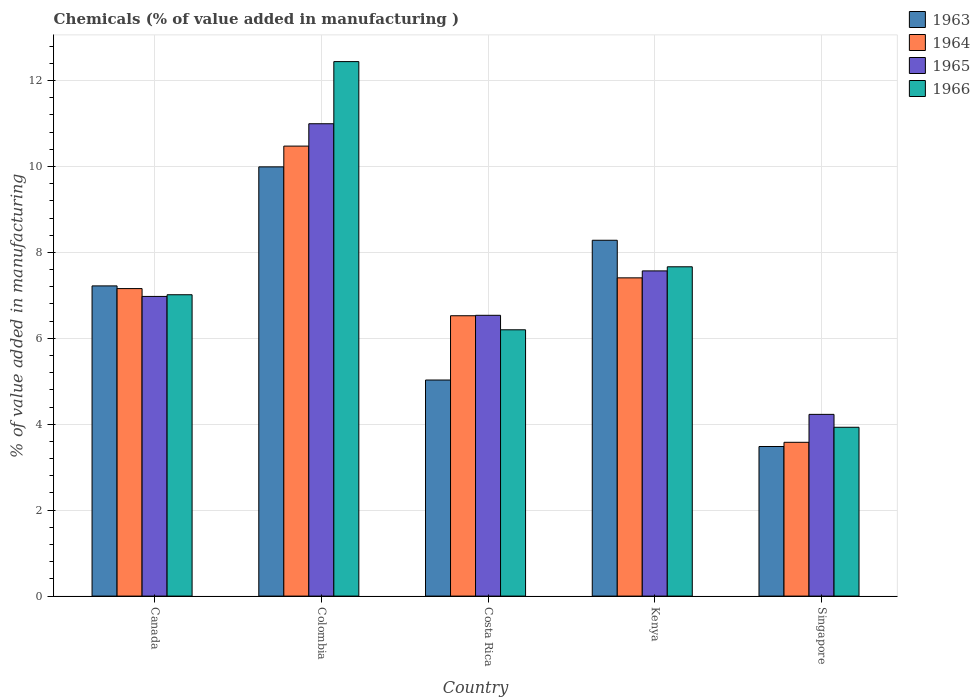How many different coloured bars are there?
Your response must be concise. 4. Are the number of bars per tick equal to the number of legend labels?
Provide a short and direct response. Yes. What is the label of the 3rd group of bars from the left?
Offer a terse response. Costa Rica. What is the value added in manufacturing chemicals in 1963 in Kenya?
Offer a terse response. 8.28. Across all countries, what is the maximum value added in manufacturing chemicals in 1965?
Ensure brevity in your answer.  10.99. Across all countries, what is the minimum value added in manufacturing chemicals in 1966?
Keep it short and to the point. 3.93. In which country was the value added in manufacturing chemicals in 1966 minimum?
Offer a terse response. Singapore. What is the total value added in manufacturing chemicals in 1963 in the graph?
Give a very brief answer. 34.01. What is the difference between the value added in manufacturing chemicals in 1966 in Costa Rica and that in Kenya?
Give a very brief answer. -1.47. What is the difference between the value added in manufacturing chemicals in 1966 in Kenya and the value added in manufacturing chemicals in 1965 in Colombia?
Your response must be concise. -3.33. What is the average value added in manufacturing chemicals in 1964 per country?
Ensure brevity in your answer.  7.03. What is the difference between the value added in manufacturing chemicals of/in 1966 and value added in manufacturing chemicals of/in 1963 in Singapore?
Provide a short and direct response. 0.45. What is the ratio of the value added in manufacturing chemicals in 1964 in Canada to that in Costa Rica?
Give a very brief answer. 1.1. Is the value added in manufacturing chemicals in 1963 in Canada less than that in Costa Rica?
Offer a terse response. No. What is the difference between the highest and the second highest value added in manufacturing chemicals in 1963?
Provide a succinct answer. -1.71. What is the difference between the highest and the lowest value added in manufacturing chemicals in 1963?
Your response must be concise. 6.51. Is the sum of the value added in manufacturing chemicals in 1966 in Canada and Colombia greater than the maximum value added in manufacturing chemicals in 1963 across all countries?
Make the answer very short. Yes. Is it the case that in every country, the sum of the value added in manufacturing chemicals in 1963 and value added in manufacturing chemicals in 1965 is greater than the sum of value added in manufacturing chemicals in 1966 and value added in manufacturing chemicals in 1964?
Provide a short and direct response. No. What does the 4th bar from the left in Canada represents?
Give a very brief answer. 1966. What does the 1st bar from the right in Costa Rica represents?
Ensure brevity in your answer.  1966. Are all the bars in the graph horizontal?
Provide a succinct answer. No. Does the graph contain any zero values?
Your answer should be compact. No. Does the graph contain grids?
Offer a terse response. Yes. Where does the legend appear in the graph?
Make the answer very short. Top right. How are the legend labels stacked?
Your answer should be very brief. Vertical. What is the title of the graph?
Provide a short and direct response. Chemicals (% of value added in manufacturing ). What is the label or title of the X-axis?
Your response must be concise. Country. What is the label or title of the Y-axis?
Your response must be concise. % of value added in manufacturing. What is the % of value added in manufacturing of 1963 in Canada?
Your answer should be compact. 7.22. What is the % of value added in manufacturing in 1964 in Canada?
Keep it short and to the point. 7.16. What is the % of value added in manufacturing in 1965 in Canada?
Your answer should be compact. 6.98. What is the % of value added in manufacturing of 1966 in Canada?
Offer a very short reply. 7.01. What is the % of value added in manufacturing of 1963 in Colombia?
Offer a terse response. 9.99. What is the % of value added in manufacturing of 1964 in Colombia?
Give a very brief answer. 10.47. What is the % of value added in manufacturing of 1965 in Colombia?
Keep it short and to the point. 10.99. What is the % of value added in manufacturing of 1966 in Colombia?
Your answer should be compact. 12.44. What is the % of value added in manufacturing in 1963 in Costa Rica?
Your response must be concise. 5.03. What is the % of value added in manufacturing in 1964 in Costa Rica?
Offer a terse response. 6.53. What is the % of value added in manufacturing of 1965 in Costa Rica?
Keep it short and to the point. 6.54. What is the % of value added in manufacturing in 1966 in Costa Rica?
Make the answer very short. 6.2. What is the % of value added in manufacturing in 1963 in Kenya?
Your response must be concise. 8.28. What is the % of value added in manufacturing in 1964 in Kenya?
Your answer should be very brief. 7.41. What is the % of value added in manufacturing in 1965 in Kenya?
Offer a terse response. 7.57. What is the % of value added in manufacturing of 1966 in Kenya?
Your answer should be very brief. 7.67. What is the % of value added in manufacturing in 1963 in Singapore?
Offer a very short reply. 3.48. What is the % of value added in manufacturing of 1964 in Singapore?
Your response must be concise. 3.58. What is the % of value added in manufacturing in 1965 in Singapore?
Provide a short and direct response. 4.23. What is the % of value added in manufacturing in 1966 in Singapore?
Give a very brief answer. 3.93. Across all countries, what is the maximum % of value added in manufacturing of 1963?
Your response must be concise. 9.99. Across all countries, what is the maximum % of value added in manufacturing in 1964?
Provide a succinct answer. 10.47. Across all countries, what is the maximum % of value added in manufacturing in 1965?
Ensure brevity in your answer.  10.99. Across all countries, what is the maximum % of value added in manufacturing in 1966?
Offer a very short reply. 12.44. Across all countries, what is the minimum % of value added in manufacturing in 1963?
Offer a very short reply. 3.48. Across all countries, what is the minimum % of value added in manufacturing of 1964?
Offer a very short reply. 3.58. Across all countries, what is the minimum % of value added in manufacturing of 1965?
Provide a succinct answer. 4.23. Across all countries, what is the minimum % of value added in manufacturing of 1966?
Give a very brief answer. 3.93. What is the total % of value added in manufacturing in 1963 in the graph?
Ensure brevity in your answer.  34.01. What is the total % of value added in manufacturing in 1964 in the graph?
Offer a very short reply. 35.15. What is the total % of value added in manufacturing of 1965 in the graph?
Provide a short and direct response. 36.31. What is the total % of value added in manufacturing of 1966 in the graph?
Make the answer very short. 37.25. What is the difference between the % of value added in manufacturing in 1963 in Canada and that in Colombia?
Provide a short and direct response. -2.77. What is the difference between the % of value added in manufacturing in 1964 in Canada and that in Colombia?
Provide a short and direct response. -3.32. What is the difference between the % of value added in manufacturing of 1965 in Canada and that in Colombia?
Ensure brevity in your answer.  -4.02. What is the difference between the % of value added in manufacturing in 1966 in Canada and that in Colombia?
Offer a terse response. -5.43. What is the difference between the % of value added in manufacturing of 1963 in Canada and that in Costa Rica?
Your answer should be very brief. 2.19. What is the difference between the % of value added in manufacturing in 1964 in Canada and that in Costa Rica?
Keep it short and to the point. 0.63. What is the difference between the % of value added in manufacturing of 1965 in Canada and that in Costa Rica?
Provide a succinct answer. 0.44. What is the difference between the % of value added in manufacturing in 1966 in Canada and that in Costa Rica?
Provide a succinct answer. 0.82. What is the difference between the % of value added in manufacturing of 1963 in Canada and that in Kenya?
Offer a very short reply. -1.06. What is the difference between the % of value added in manufacturing of 1964 in Canada and that in Kenya?
Keep it short and to the point. -0.25. What is the difference between the % of value added in manufacturing of 1965 in Canada and that in Kenya?
Offer a very short reply. -0.59. What is the difference between the % of value added in manufacturing in 1966 in Canada and that in Kenya?
Keep it short and to the point. -0.65. What is the difference between the % of value added in manufacturing in 1963 in Canada and that in Singapore?
Your response must be concise. 3.74. What is the difference between the % of value added in manufacturing of 1964 in Canada and that in Singapore?
Offer a terse response. 3.58. What is the difference between the % of value added in manufacturing of 1965 in Canada and that in Singapore?
Provide a succinct answer. 2.75. What is the difference between the % of value added in manufacturing of 1966 in Canada and that in Singapore?
Ensure brevity in your answer.  3.08. What is the difference between the % of value added in manufacturing in 1963 in Colombia and that in Costa Rica?
Ensure brevity in your answer.  4.96. What is the difference between the % of value added in manufacturing of 1964 in Colombia and that in Costa Rica?
Make the answer very short. 3.95. What is the difference between the % of value added in manufacturing in 1965 in Colombia and that in Costa Rica?
Make the answer very short. 4.46. What is the difference between the % of value added in manufacturing in 1966 in Colombia and that in Costa Rica?
Provide a succinct answer. 6.24. What is the difference between the % of value added in manufacturing in 1963 in Colombia and that in Kenya?
Make the answer very short. 1.71. What is the difference between the % of value added in manufacturing of 1964 in Colombia and that in Kenya?
Provide a short and direct response. 3.07. What is the difference between the % of value added in manufacturing of 1965 in Colombia and that in Kenya?
Your answer should be very brief. 3.43. What is the difference between the % of value added in manufacturing in 1966 in Colombia and that in Kenya?
Keep it short and to the point. 4.78. What is the difference between the % of value added in manufacturing in 1963 in Colombia and that in Singapore?
Offer a very short reply. 6.51. What is the difference between the % of value added in manufacturing in 1964 in Colombia and that in Singapore?
Your answer should be very brief. 6.89. What is the difference between the % of value added in manufacturing in 1965 in Colombia and that in Singapore?
Ensure brevity in your answer.  6.76. What is the difference between the % of value added in manufacturing in 1966 in Colombia and that in Singapore?
Make the answer very short. 8.51. What is the difference between the % of value added in manufacturing of 1963 in Costa Rica and that in Kenya?
Your answer should be very brief. -3.25. What is the difference between the % of value added in manufacturing of 1964 in Costa Rica and that in Kenya?
Your response must be concise. -0.88. What is the difference between the % of value added in manufacturing in 1965 in Costa Rica and that in Kenya?
Offer a very short reply. -1.03. What is the difference between the % of value added in manufacturing in 1966 in Costa Rica and that in Kenya?
Give a very brief answer. -1.47. What is the difference between the % of value added in manufacturing in 1963 in Costa Rica and that in Singapore?
Ensure brevity in your answer.  1.55. What is the difference between the % of value added in manufacturing of 1964 in Costa Rica and that in Singapore?
Provide a succinct answer. 2.95. What is the difference between the % of value added in manufacturing of 1965 in Costa Rica and that in Singapore?
Offer a terse response. 2.31. What is the difference between the % of value added in manufacturing in 1966 in Costa Rica and that in Singapore?
Make the answer very short. 2.27. What is the difference between the % of value added in manufacturing of 1963 in Kenya and that in Singapore?
Your answer should be compact. 4.8. What is the difference between the % of value added in manufacturing of 1964 in Kenya and that in Singapore?
Make the answer very short. 3.83. What is the difference between the % of value added in manufacturing in 1965 in Kenya and that in Singapore?
Your response must be concise. 3.34. What is the difference between the % of value added in manufacturing of 1966 in Kenya and that in Singapore?
Ensure brevity in your answer.  3.74. What is the difference between the % of value added in manufacturing in 1963 in Canada and the % of value added in manufacturing in 1964 in Colombia?
Your answer should be compact. -3.25. What is the difference between the % of value added in manufacturing in 1963 in Canada and the % of value added in manufacturing in 1965 in Colombia?
Your answer should be very brief. -3.77. What is the difference between the % of value added in manufacturing of 1963 in Canada and the % of value added in manufacturing of 1966 in Colombia?
Offer a very short reply. -5.22. What is the difference between the % of value added in manufacturing of 1964 in Canada and the % of value added in manufacturing of 1965 in Colombia?
Provide a succinct answer. -3.84. What is the difference between the % of value added in manufacturing in 1964 in Canada and the % of value added in manufacturing in 1966 in Colombia?
Keep it short and to the point. -5.28. What is the difference between the % of value added in manufacturing in 1965 in Canada and the % of value added in manufacturing in 1966 in Colombia?
Ensure brevity in your answer.  -5.47. What is the difference between the % of value added in manufacturing of 1963 in Canada and the % of value added in manufacturing of 1964 in Costa Rica?
Offer a terse response. 0.69. What is the difference between the % of value added in manufacturing of 1963 in Canada and the % of value added in manufacturing of 1965 in Costa Rica?
Your response must be concise. 0.68. What is the difference between the % of value added in manufacturing in 1963 in Canada and the % of value added in manufacturing in 1966 in Costa Rica?
Keep it short and to the point. 1.02. What is the difference between the % of value added in manufacturing in 1964 in Canada and the % of value added in manufacturing in 1965 in Costa Rica?
Offer a terse response. 0.62. What is the difference between the % of value added in manufacturing in 1964 in Canada and the % of value added in manufacturing in 1966 in Costa Rica?
Your answer should be compact. 0.96. What is the difference between the % of value added in manufacturing in 1965 in Canada and the % of value added in manufacturing in 1966 in Costa Rica?
Your response must be concise. 0.78. What is the difference between the % of value added in manufacturing of 1963 in Canada and the % of value added in manufacturing of 1964 in Kenya?
Your response must be concise. -0.19. What is the difference between the % of value added in manufacturing in 1963 in Canada and the % of value added in manufacturing in 1965 in Kenya?
Ensure brevity in your answer.  -0.35. What is the difference between the % of value added in manufacturing of 1963 in Canada and the % of value added in manufacturing of 1966 in Kenya?
Your answer should be compact. -0.44. What is the difference between the % of value added in manufacturing in 1964 in Canada and the % of value added in manufacturing in 1965 in Kenya?
Your response must be concise. -0.41. What is the difference between the % of value added in manufacturing of 1964 in Canada and the % of value added in manufacturing of 1966 in Kenya?
Keep it short and to the point. -0.51. What is the difference between the % of value added in manufacturing of 1965 in Canada and the % of value added in manufacturing of 1966 in Kenya?
Offer a terse response. -0.69. What is the difference between the % of value added in manufacturing of 1963 in Canada and the % of value added in manufacturing of 1964 in Singapore?
Your answer should be very brief. 3.64. What is the difference between the % of value added in manufacturing of 1963 in Canada and the % of value added in manufacturing of 1965 in Singapore?
Your answer should be very brief. 2.99. What is the difference between the % of value added in manufacturing in 1963 in Canada and the % of value added in manufacturing in 1966 in Singapore?
Offer a very short reply. 3.29. What is the difference between the % of value added in manufacturing in 1964 in Canada and the % of value added in manufacturing in 1965 in Singapore?
Offer a very short reply. 2.93. What is the difference between the % of value added in manufacturing of 1964 in Canada and the % of value added in manufacturing of 1966 in Singapore?
Provide a short and direct response. 3.23. What is the difference between the % of value added in manufacturing of 1965 in Canada and the % of value added in manufacturing of 1966 in Singapore?
Keep it short and to the point. 3.05. What is the difference between the % of value added in manufacturing in 1963 in Colombia and the % of value added in manufacturing in 1964 in Costa Rica?
Keep it short and to the point. 3.47. What is the difference between the % of value added in manufacturing of 1963 in Colombia and the % of value added in manufacturing of 1965 in Costa Rica?
Your answer should be compact. 3.46. What is the difference between the % of value added in manufacturing in 1963 in Colombia and the % of value added in manufacturing in 1966 in Costa Rica?
Make the answer very short. 3.79. What is the difference between the % of value added in manufacturing in 1964 in Colombia and the % of value added in manufacturing in 1965 in Costa Rica?
Provide a short and direct response. 3.94. What is the difference between the % of value added in manufacturing in 1964 in Colombia and the % of value added in manufacturing in 1966 in Costa Rica?
Your response must be concise. 4.28. What is the difference between the % of value added in manufacturing of 1965 in Colombia and the % of value added in manufacturing of 1966 in Costa Rica?
Keep it short and to the point. 4.8. What is the difference between the % of value added in manufacturing in 1963 in Colombia and the % of value added in manufacturing in 1964 in Kenya?
Your response must be concise. 2.58. What is the difference between the % of value added in manufacturing in 1963 in Colombia and the % of value added in manufacturing in 1965 in Kenya?
Offer a terse response. 2.42. What is the difference between the % of value added in manufacturing in 1963 in Colombia and the % of value added in manufacturing in 1966 in Kenya?
Ensure brevity in your answer.  2.33. What is the difference between the % of value added in manufacturing of 1964 in Colombia and the % of value added in manufacturing of 1965 in Kenya?
Ensure brevity in your answer.  2.9. What is the difference between the % of value added in manufacturing in 1964 in Colombia and the % of value added in manufacturing in 1966 in Kenya?
Ensure brevity in your answer.  2.81. What is the difference between the % of value added in manufacturing in 1965 in Colombia and the % of value added in manufacturing in 1966 in Kenya?
Offer a terse response. 3.33. What is the difference between the % of value added in manufacturing in 1963 in Colombia and the % of value added in manufacturing in 1964 in Singapore?
Your answer should be compact. 6.41. What is the difference between the % of value added in manufacturing of 1963 in Colombia and the % of value added in manufacturing of 1965 in Singapore?
Give a very brief answer. 5.76. What is the difference between the % of value added in manufacturing of 1963 in Colombia and the % of value added in manufacturing of 1966 in Singapore?
Keep it short and to the point. 6.06. What is the difference between the % of value added in manufacturing of 1964 in Colombia and the % of value added in manufacturing of 1965 in Singapore?
Offer a very short reply. 6.24. What is the difference between the % of value added in manufacturing in 1964 in Colombia and the % of value added in manufacturing in 1966 in Singapore?
Make the answer very short. 6.54. What is the difference between the % of value added in manufacturing in 1965 in Colombia and the % of value added in manufacturing in 1966 in Singapore?
Offer a very short reply. 7.07. What is the difference between the % of value added in manufacturing in 1963 in Costa Rica and the % of value added in manufacturing in 1964 in Kenya?
Give a very brief answer. -2.38. What is the difference between the % of value added in manufacturing of 1963 in Costa Rica and the % of value added in manufacturing of 1965 in Kenya?
Give a very brief answer. -2.54. What is the difference between the % of value added in manufacturing in 1963 in Costa Rica and the % of value added in manufacturing in 1966 in Kenya?
Give a very brief answer. -2.64. What is the difference between the % of value added in manufacturing in 1964 in Costa Rica and the % of value added in manufacturing in 1965 in Kenya?
Provide a succinct answer. -1.04. What is the difference between the % of value added in manufacturing of 1964 in Costa Rica and the % of value added in manufacturing of 1966 in Kenya?
Provide a succinct answer. -1.14. What is the difference between the % of value added in manufacturing of 1965 in Costa Rica and the % of value added in manufacturing of 1966 in Kenya?
Offer a very short reply. -1.13. What is the difference between the % of value added in manufacturing of 1963 in Costa Rica and the % of value added in manufacturing of 1964 in Singapore?
Ensure brevity in your answer.  1.45. What is the difference between the % of value added in manufacturing in 1963 in Costa Rica and the % of value added in manufacturing in 1965 in Singapore?
Your answer should be very brief. 0.8. What is the difference between the % of value added in manufacturing in 1963 in Costa Rica and the % of value added in manufacturing in 1966 in Singapore?
Give a very brief answer. 1.1. What is the difference between the % of value added in manufacturing of 1964 in Costa Rica and the % of value added in manufacturing of 1965 in Singapore?
Provide a succinct answer. 2.3. What is the difference between the % of value added in manufacturing of 1964 in Costa Rica and the % of value added in manufacturing of 1966 in Singapore?
Offer a very short reply. 2.6. What is the difference between the % of value added in manufacturing of 1965 in Costa Rica and the % of value added in manufacturing of 1966 in Singapore?
Provide a short and direct response. 2.61. What is the difference between the % of value added in manufacturing in 1963 in Kenya and the % of value added in manufacturing in 1964 in Singapore?
Offer a terse response. 4.7. What is the difference between the % of value added in manufacturing of 1963 in Kenya and the % of value added in manufacturing of 1965 in Singapore?
Offer a terse response. 4.05. What is the difference between the % of value added in manufacturing of 1963 in Kenya and the % of value added in manufacturing of 1966 in Singapore?
Offer a very short reply. 4.35. What is the difference between the % of value added in manufacturing in 1964 in Kenya and the % of value added in manufacturing in 1965 in Singapore?
Your answer should be compact. 3.18. What is the difference between the % of value added in manufacturing of 1964 in Kenya and the % of value added in manufacturing of 1966 in Singapore?
Your answer should be very brief. 3.48. What is the difference between the % of value added in manufacturing in 1965 in Kenya and the % of value added in manufacturing in 1966 in Singapore?
Offer a very short reply. 3.64. What is the average % of value added in manufacturing in 1963 per country?
Make the answer very short. 6.8. What is the average % of value added in manufacturing of 1964 per country?
Provide a short and direct response. 7.03. What is the average % of value added in manufacturing of 1965 per country?
Provide a succinct answer. 7.26. What is the average % of value added in manufacturing of 1966 per country?
Offer a terse response. 7.45. What is the difference between the % of value added in manufacturing of 1963 and % of value added in manufacturing of 1964 in Canada?
Make the answer very short. 0.06. What is the difference between the % of value added in manufacturing in 1963 and % of value added in manufacturing in 1965 in Canada?
Provide a succinct answer. 0.25. What is the difference between the % of value added in manufacturing of 1963 and % of value added in manufacturing of 1966 in Canada?
Ensure brevity in your answer.  0.21. What is the difference between the % of value added in manufacturing of 1964 and % of value added in manufacturing of 1965 in Canada?
Keep it short and to the point. 0.18. What is the difference between the % of value added in manufacturing of 1964 and % of value added in manufacturing of 1966 in Canada?
Make the answer very short. 0.14. What is the difference between the % of value added in manufacturing of 1965 and % of value added in manufacturing of 1966 in Canada?
Give a very brief answer. -0.04. What is the difference between the % of value added in manufacturing of 1963 and % of value added in manufacturing of 1964 in Colombia?
Keep it short and to the point. -0.48. What is the difference between the % of value added in manufacturing in 1963 and % of value added in manufacturing in 1965 in Colombia?
Offer a very short reply. -1. What is the difference between the % of value added in manufacturing in 1963 and % of value added in manufacturing in 1966 in Colombia?
Your answer should be very brief. -2.45. What is the difference between the % of value added in manufacturing of 1964 and % of value added in manufacturing of 1965 in Colombia?
Make the answer very short. -0.52. What is the difference between the % of value added in manufacturing in 1964 and % of value added in manufacturing in 1966 in Colombia?
Provide a short and direct response. -1.97. What is the difference between the % of value added in manufacturing of 1965 and % of value added in manufacturing of 1966 in Colombia?
Make the answer very short. -1.45. What is the difference between the % of value added in manufacturing of 1963 and % of value added in manufacturing of 1964 in Costa Rica?
Offer a terse response. -1.5. What is the difference between the % of value added in manufacturing of 1963 and % of value added in manufacturing of 1965 in Costa Rica?
Offer a terse response. -1.51. What is the difference between the % of value added in manufacturing of 1963 and % of value added in manufacturing of 1966 in Costa Rica?
Offer a terse response. -1.17. What is the difference between the % of value added in manufacturing of 1964 and % of value added in manufacturing of 1965 in Costa Rica?
Give a very brief answer. -0.01. What is the difference between the % of value added in manufacturing of 1964 and % of value added in manufacturing of 1966 in Costa Rica?
Make the answer very short. 0.33. What is the difference between the % of value added in manufacturing in 1965 and % of value added in manufacturing in 1966 in Costa Rica?
Your response must be concise. 0.34. What is the difference between the % of value added in manufacturing in 1963 and % of value added in manufacturing in 1964 in Kenya?
Your answer should be compact. 0.87. What is the difference between the % of value added in manufacturing of 1963 and % of value added in manufacturing of 1965 in Kenya?
Your answer should be compact. 0.71. What is the difference between the % of value added in manufacturing in 1963 and % of value added in manufacturing in 1966 in Kenya?
Provide a short and direct response. 0.62. What is the difference between the % of value added in manufacturing of 1964 and % of value added in manufacturing of 1965 in Kenya?
Offer a terse response. -0.16. What is the difference between the % of value added in manufacturing in 1964 and % of value added in manufacturing in 1966 in Kenya?
Make the answer very short. -0.26. What is the difference between the % of value added in manufacturing in 1965 and % of value added in manufacturing in 1966 in Kenya?
Offer a very short reply. -0.1. What is the difference between the % of value added in manufacturing of 1963 and % of value added in manufacturing of 1964 in Singapore?
Make the answer very short. -0.1. What is the difference between the % of value added in manufacturing of 1963 and % of value added in manufacturing of 1965 in Singapore?
Make the answer very short. -0.75. What is the difference between the % of value added in manufacturing of 1963 and % of value added in manufacturing of 1966 in Singapore?
Offer a very short reply. -0.45. What is the difference between the % of value added in manufacturing in 1964 and % of value added in manufacturing in 1965 in Singapore?
Keep it short and to the point. -0.65. What is the difference between the % of value added in manufacturing in 1964 and % of value added in manufacturing in 1966 in Singapore?
Provide a short and direct response. -0.35. What is the difference between the % of value added in manufacturing of 1965 and % of value added in manufacturing of 1966 in Singapore?
Your answer should be compact. 0.3. What is the ratio of the % of value added in manufacturing in 1963 in Canada to that in Colombia?
Your response must be concise. 0.72. What is the ratio of the % of value added in manufacturing in 1964 in Canada to that in Colombia?
Provide a short and direct response. 0.68. What is the ratio of the % of value added in manufacturing in 1965 in Canada to that in Colombia?
Offer a very short reply. 0.63. What is the ratio of the % of value added in manufacturing in 1966 in Canada to that in Colombia?
Provide a succinct answer. 0.56. What is the ratio of the % of value added in manufacturing in 1963 in Canada to that in Costa Rica?
Give a very brief answer. 1.44. What is the ratio of the % of value added in manufacturing in 1964 in Canada to that in Costa Rica?
Provide a short and direct response. 1.1. What is the ratio of the % of value added in manufacturing in 1965 in Canada to that in Costa Rica?
Your answer should be compact. 1.07. What is the ratio of the % of value added in manufacturing of 1966 in Canada to that in Costa Rica?
Provide a short and direct response. 1.13. What is the ratio of the % of value added in manufacturing of 1963 in Canada to that in Kenya?
Keep it short and to the point. 0.87. What is the ratio of the % of value added in manufacturing in 1964 in Canada to that in Kenya?
Provide a succinct answer. 0.97. What is the ratio of the % of value added in manufacturing of 1965 in Canada to that in Kenya?
Ensure brevity in your answer.  0.92. What is the ratio of the % of value added in manufacturing in 1966 in Canada to that in Kenya?
Offer a terse response. 0.92. What is the ratio of the % of value added in manufacturing of 1963 in Canada to that in Singapore?
Offer a very short reply. 2.07. What is the ratio of the % of value added in manufacturing of 1964 in Canada to that in Singapore?
Ensure brevity in your answer.  2. What is the ratio of the % of value added in manufacturing of 1965 in Canada to that in Singapore?
Your answer should be compact. 1.65. What is the ratio of the % of value added in manufacturing in 1966 in Canada to that in Singapore?
Provide a short and direct response. 1.78. What is the ratio of the % of value added in manufacturing of 1963 in Colombia to that in Costa Rica?
Offer a terse response. 1.99. What is the ratio of the % of value added in manufacturing in 1964 in Colombia to that in Costa Rica?
Provide a short and direct response. 1.61. What is the ratio of the % of value added in manufacturing in 1965 in Colombia to that in Costa Rica?
Give a very brief answer. 1.68. What is the ratio of the % of value added in manufacturing in 1966 in Colombia to that in Costa Rica?
Your answer should be compact. 2.01. What is the ratio of the % of value added in manufacturing in 1963 in Colombia to that in Kenya?
Make the answer very short. 1.21. What is the ratio of the % of value added in manufacturing in 1964 in Colombia to that in Kenya?
Your answer should be compact. 1.41. What is the ratio of the % of value added in manufacturing in 1965 in Colombia to that in Kenya?
Your answer should be very brief. 1.45. What is the ratio of the % of value added in manufacturing of 1966 in Colombia to that in Kenya?
Your answer should be very brief. 1.62. What is the ratio of the % of value added in manufacturing in 1963 in Colombia to that in Singapore?
Ensure brevity in your answer.  2.87. What is the ratio of the % of value added in manufacturing in 1964 in Colombia to that in Singapore?
Offer a terse response. 2.93. What is the ratio of the % of value added in manufacturing of 1965 in Colombia to that in Singapore?
Provide a short and direct response. 2.6. What is the ratio of the % of value added in manufacturing in 1966 in Colombia to that in Singapore?
Your answer should be compact. 3.17. What is the ratio of the % of value added in manufacturing of 1963 in Costa Rica to that in Kenya?
Provide a succinct answer. 0.61. What is the ratio of the % of value added in manufacturing of 1964 in Costa Rica to that in Kenya?
Your answer should be compact. 0.88. What is the ratio of the % of value added in manufacturing in 1965 in Costa Rica to that in Kenya?
Your answer should be very brief. 0.86. What is the ratio of the % of value added in manufacturing of 1966 in Costa Rica to that in Kenya?
Provide a short and direct response. 0.81. What is the ratio of the % of value added in manufacturing of 1963 in Costa Rica to that in Singapore?
Your answer should be very brief. 1.44. What is the ratio of the % of value added in manufacturing in 1964 in Costa Rica to that in Singapore?
Ensure brevity in your answer.  1.82. What is the ratio of the % of value added in manufacturing of 1965 in Costa Rica to that in Singapore?
Your answer should be very brief. 1.55. What is the ratio of the % of value added in manufacturing in 1966 in Costa Rica to that in Singapore?
Make the answer very short. 1.58. What is the ratio of the % of value added in manufacturing of 1963 in Kenya to that in Singapore?
Ensure brevity in your answer.  2.38. What is the ratio of the % of value added in manufacturing of 1964 in Kenya to that in Singapore?
Make the answer very short. 2.07. What is the ratio of the % of value added in manufacturing in 1965 in Kenya to that in Singapore?
Provide a succinct answer. 1.79. What is the ratio of the % of value added in manufacturing of 1966 in Kenya to that in Singapore?
Your response must be concise. 1.95. What is the difference between the highest and the second highest % of value added in manufacturing of 1963?
Make the answer very short. 1.71. What is the difference between the highest and the second highest % of value added in manufacturing in 1964?
Your answer should be very brief. 3.07. What is the difference between the highest and the second highest % of value added in manufacturing of 1965?
Make the answer very short. 3.43. What is the difference between the highest and the second highest % of value added in manufacturing of 1966?
Provide a short and direct response. 4.78. What is the difference between the highest and the lowest % of value added in manufacturing of 1963?
Provide a short and direct response. 6.51. What is the difference between the highest and the lowest % of value added in manufacturing of 1964?
Provide a succinct answer. 6.89. What is the difference between the highest and the lowest % of value added in manufacturing in 1965?
Keep it short and to the point. 6.76. What is the difference between the highest and the lowest % of value added in manufacturing of 1966?
Offer a terse response. 8.51. 